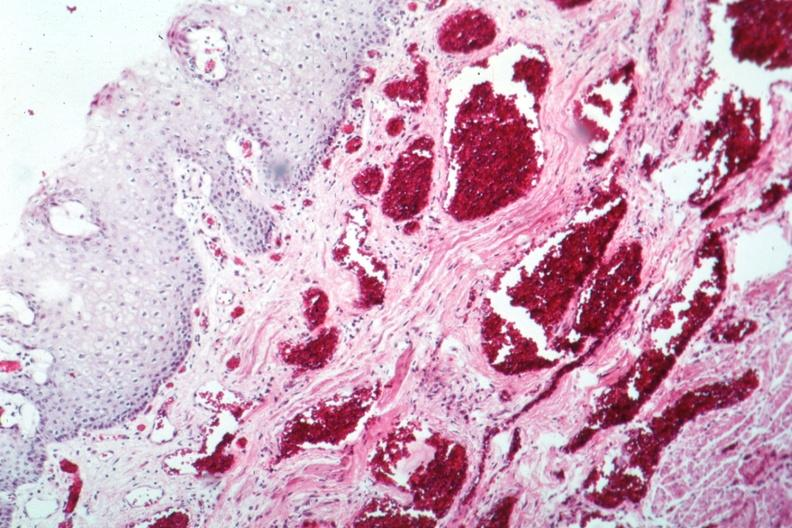s cystadenocarcinoma malignancy present?
Answer the question using a single word or phrase. No 